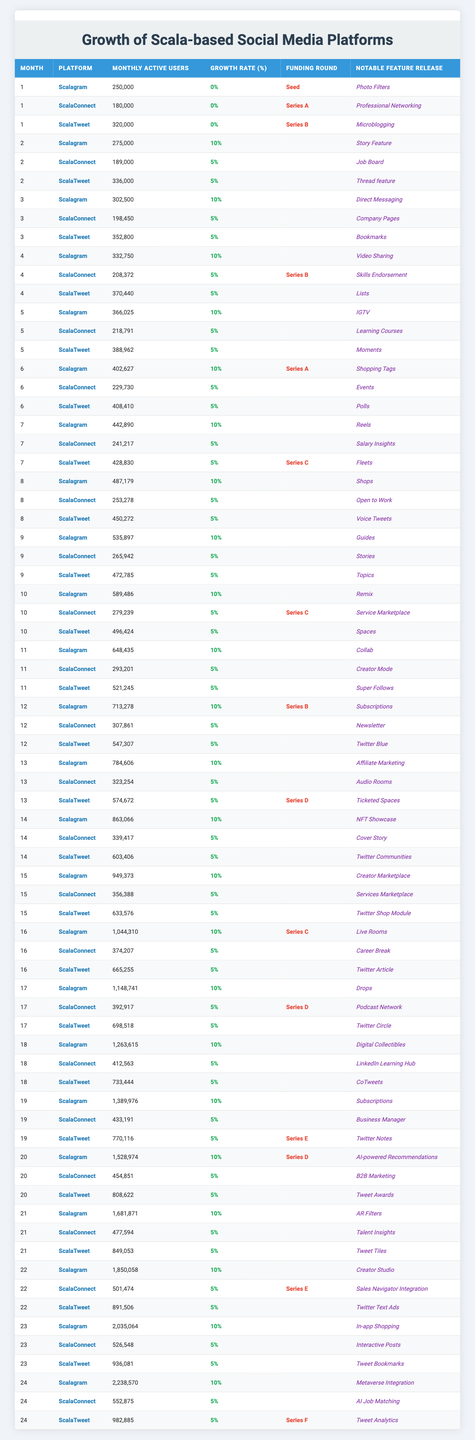What was the highest Monthly Active Users (MAU) count for Scalagram in any month? By inspecting the "Monthly Active Users" column for Scalagram, the highest value is at Month 24, with 2,238,570 users.
Answer: 2,238,570 Which platform had the highest growth rate in Month 6? In Month 6, Scalagram had a consistent growth rate of 10%, while both ScalaConnect and ScalaTweet had a growth rate of 5%. Thus, Scalagram had the highest growth rate for that month.
Answer: Scalagram What is the total number of Monthly Active Users for ScalaConnect over the first 12 months combined? By adding the Monthly Active Users for ScalaConnect for each of the first 12 months, the total is calculated as follows: 180,000 + 189,000 + 198,450 + 208,372 + 218,791 + 229,730 + 241,217 + 253,278 + 265,942 + 279,239 + 293,201 + 307,861 = 3,061,525.
Answer: 3,061,525 Did ScalaTweet receive funding in its funding rounds in Month 10? According to the table, ScalaTweet did not receive any funding in Month 10, as the funding round column is empty for that month.
Answer: No What was the average Monthly Active Users for ScalaConnect over the entire 24 months? To calculate the average, sum the Monthly Active Users for ScalaConnect over 24 months, which totals 12,083,228, and then divide by 24. This gives the average of 502,927.
Answer: 502,927 How did the Monthly Active Users of ScalaTweet change from Month 1 to Month 24? In Month 1, ScalaTweet had 320,000 Monthly Active Users, and by Month 24, this increased to 982,885. The change is an increase of 662,885 users over the 24 months.
Answer: Increased by 662,885 Which notable feature release was associated with the highest user count for Scalagram in Month 24? In Month 24, Scalagram had 2,238,570 users, and the notable feature release associated with this count was "Metaverse Integration."
Answer: Metaverse Integration Was there any month where the growth rate for any platform reached 15%? Looking at the "Growth Rate (%)" column for all platforms, no month had a growth rate of 15% or higher, as the maximum observed was 10%.
Answer: No During which month did ScalaConnect reach its highest Monthly Active Users and what was that count? The highest Monthly Active Users for ScalaConnect was 552,875 in Month 24.
Answer: Month 24 with 552,875 users What is the cumulative growth in Monthly Active Users for Scalagram from Month 1 to Month 24? In Month 1, Scalagram had 250,000 users and grew to 2,238,570 users in Month 24. The cumulative growth is 2,238,570 - 250,000 = 1,988,570 users.
Answer: 1,988,570 